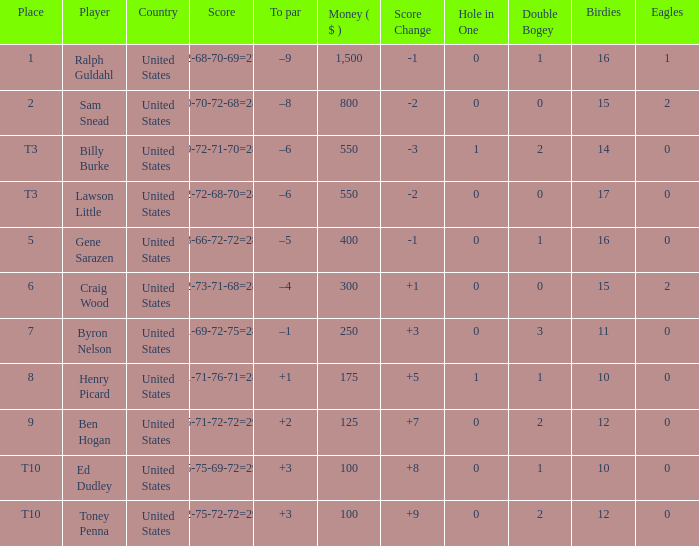Which to par has a prize below $800? –8. 